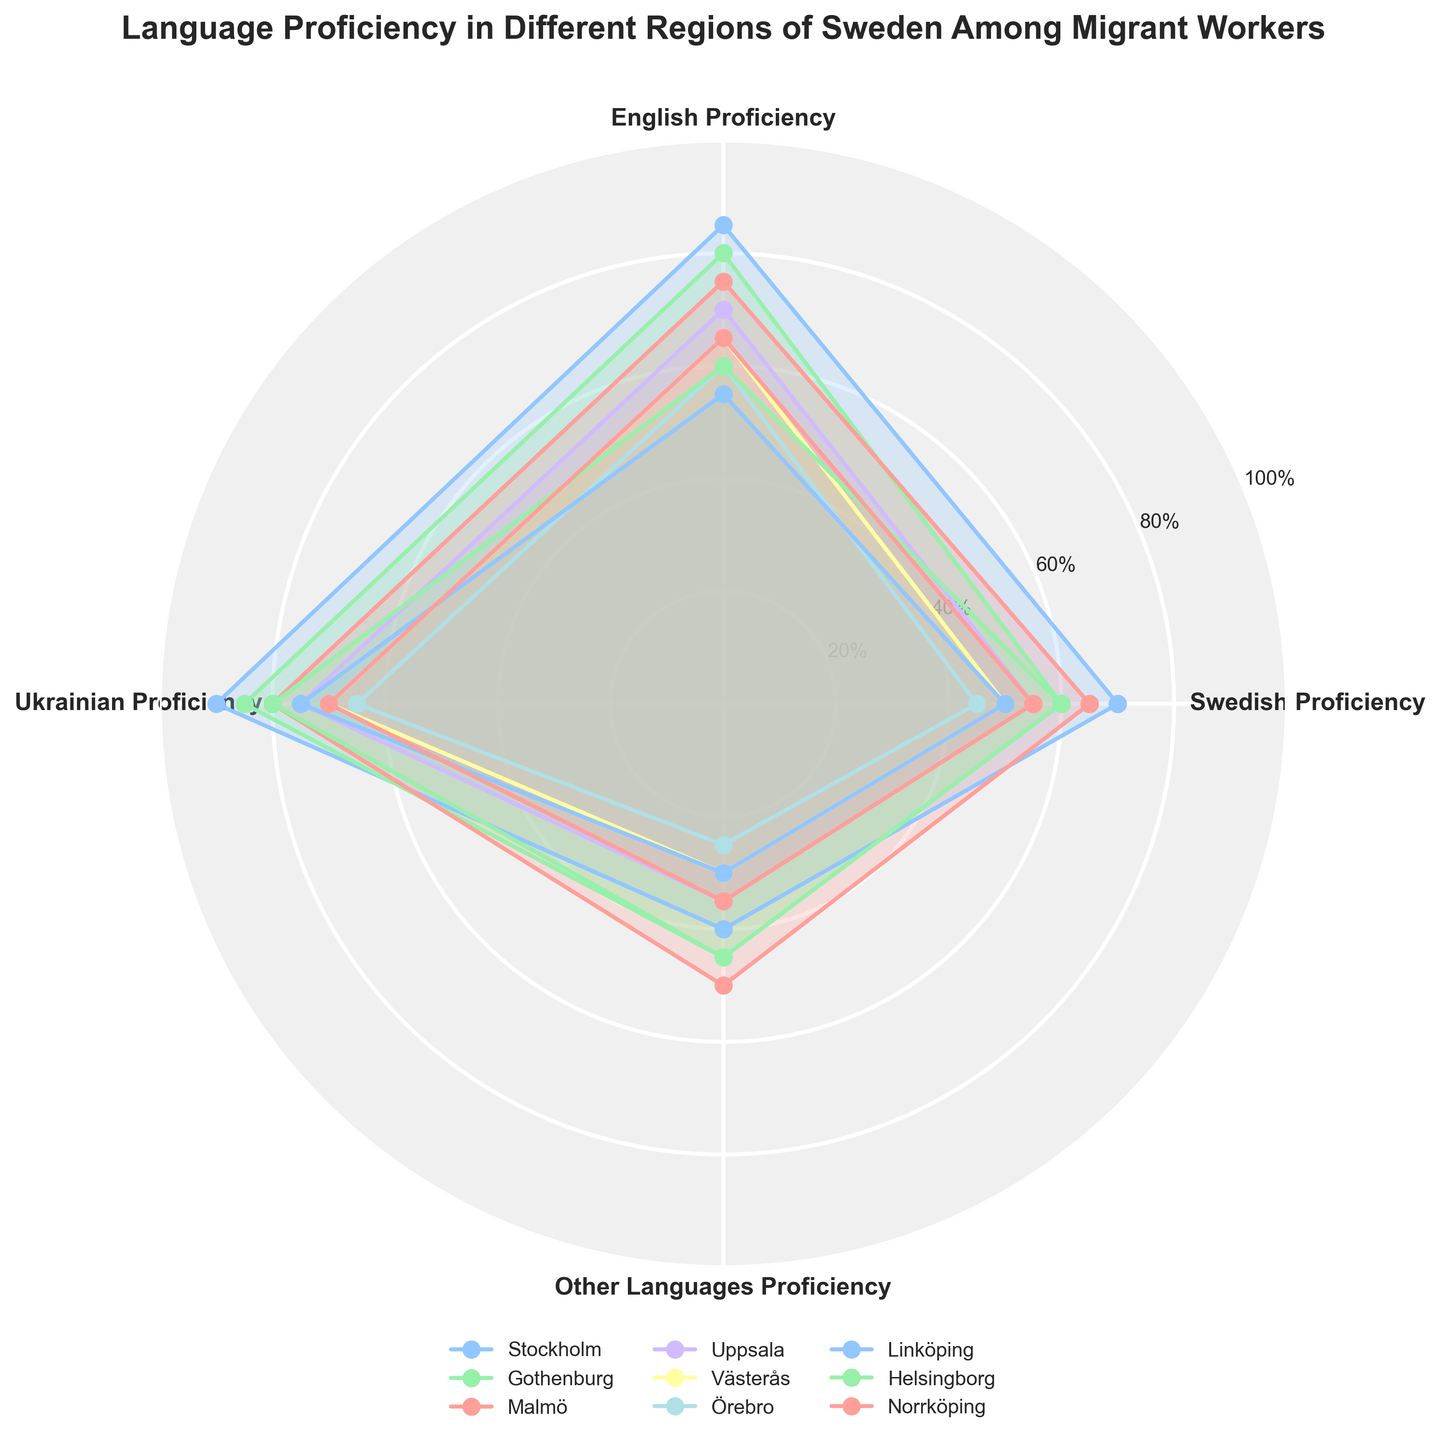What's the title of the chart? The title is located at the top of the chart; it displays the overall topic of the figure.
Answer: Language Proficiency in Different Regions of Sweden Among Migrant Workers What are the languages proficiencies represented in the chart? The labels on the surrounding axis of the polar chart indicate the categories, representing different language proficiencies.
Answer: Swedish, English, Ukrainian, Other Languages Which region shows the highest proficiency in English? Look for the region label around the plotted lines and find the one which reaches the highest value on the English proficiency axis.
Answer: Stockholm Which two regions have the highest proficiency in Ukrainian? Observe the lines extending towards the Ukrainian proficiency axis, focusing on the two longest ones.
Answer: Stockholm and Gothenburg On average, which region has the lowest overall language proficiency? Evaluate the area covered within the lines for all categories for each region and compare, focusing on the smallest one.
Answer: Örebro How does Gothenburg compare to Malmö in terms of Swedish proficiency? Compare the values on the Swedish proficiency axis for Gothenburg and Malmö.
Answer: Gothenburg has lower proficiency Which region has a higher proficiency in Other Languages: Uppsala or Linköping? Check the values on the Other Languages proficiency axis for both Uppsala and Linköping, compare the two.
Answer: Linköping In terms of English proficiency, which region performs better: Helsingborg or Västerås? Compare the plotted points on the English proficiency axis for Helsingborg and Västerås.
Answer: Helsingborg What is common in terms of language proficiency levels between Uppsala and Norrköping? Identify the pattern for both Uppsala and Norrköping across each language proficiency category; find common values.
Answer: They both have similar proficiency in Other Languages Which two regions have similar patterns in proficiency across all languages? Compare the shapes and sizes of the areas enclosed by the lines for each region. Identify two regions that overlap closely in all categories.
Answer: Norrköping and Västerås 